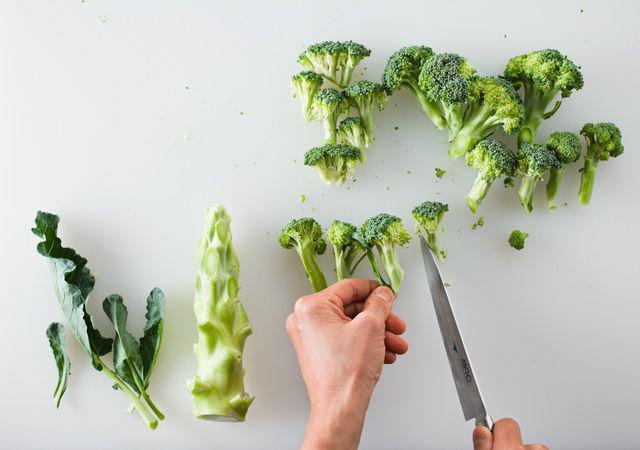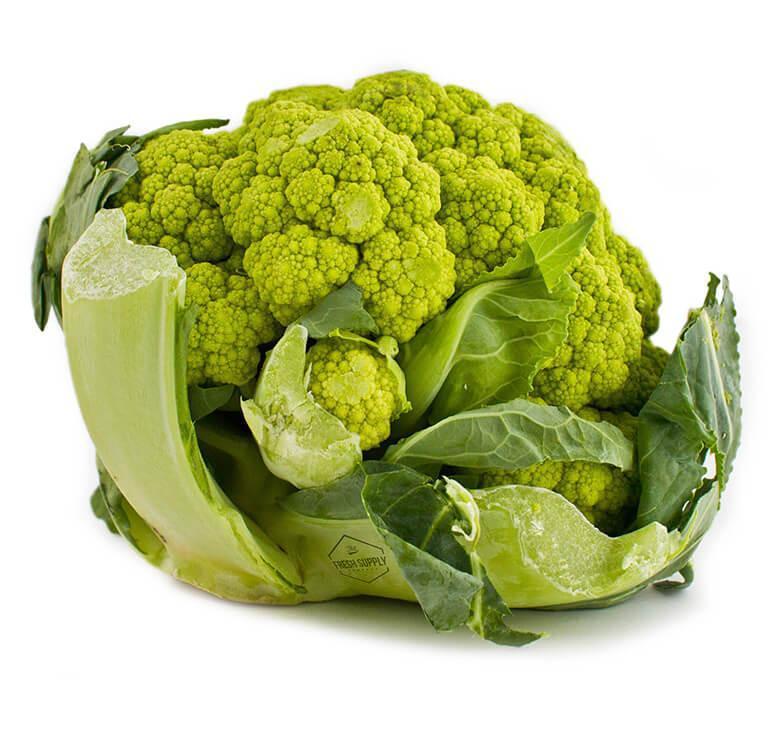The first image is the image on the left, the second image is the image on the right. For the images displayed, is the sentence "One image shows one roundish head of a yellow-green cauliflower type vegetable, and the other image features darker green broccoli florets." factually correct? Answer yes or no. Yes. The first image is the image on the left, the second image is the image on the right. Assess this claim about the two images: "In at least one image there is a single head of green cauliflower.". Correct or not? Answer yes or no. Yes. 